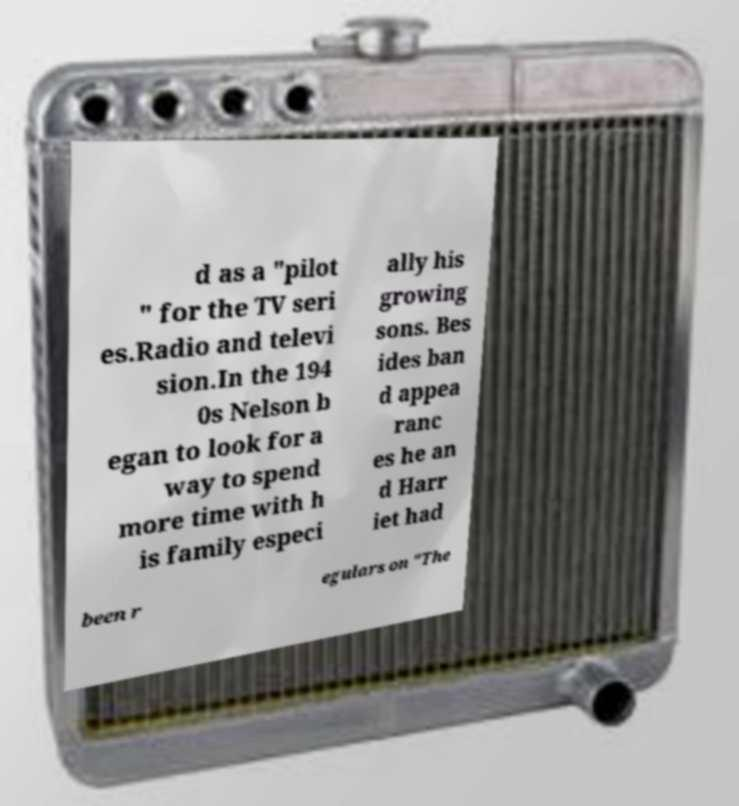Could you extract and type out the text from this image? d as a "pilot " for the TV seri es.Radio and televi sion.In the 194 0s Nelson b egan to look for a way to spend more time with h is family especi ally his growing sons. Bes ides ban d appea ranc es he an d Harr iet had been r egulars on "The 